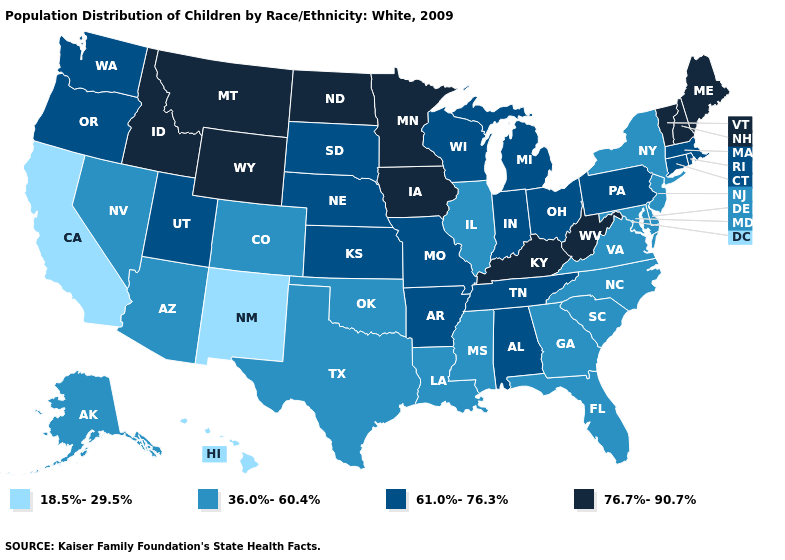Does Tennessee have a higher value than Vermont?
Write a very short answer. No. Does North Dakota have the lowest value in the USA?
Keep it brief. No. What is the value of Delaware?
Short answer required. 36.0%-60.4%. Does Florida have the same value as Wyoming?
Quick response, please. No. Does North Carolina have a lower value than Kentucky?
Be succinct. Yes. Does New Hampshire have the highest value in the USA?
Concise answer only. Yes. Is the legend a continuous bar?
Give a very brief answer. No. Does Louisiana have the same value as Florida?
Answer briefly. Yes. Does the first symbol in the legend represent the smallest category?
Write a very short answer. Yes. Is the legend a continuous bar?
Write a very short answer. No. Name the states that have a value in the range 61.0%-76.3%?
Quick response, please. Alabama, Arkansas, Connecticut, Indiana, Kansas, Massachusetts, Michigan, Missouri, Nebraska, Ohio, Oregon, Pennsylvania, Rhode Island, South Dakota, Tennessee, Utah, Washington, Wisconsin. Which states have the highest value in the USA?
Be succinct. Idaho, Iowa, Kentucky, Maine, Minnesota, Montana, New Hampshire, North Dakota, Vermont, West Virginia, Wyoming. Among the states that border Vermont , which have the highest value?
Be succinct. New Hampshire. Which states have the lowest value in the South?
Quick response, please. Delaware, Florida, Georgia, Louisiana, Maryland, Mississippi, North Carolina, Oklahoma, South Carolina, Texas, Virginia. Does Rhode Island have the lowest value in the Northeast?
Quick response, please. No. 